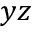<formula> <loc_0><loc_0><loc_500><loc_500>y z</formula> 